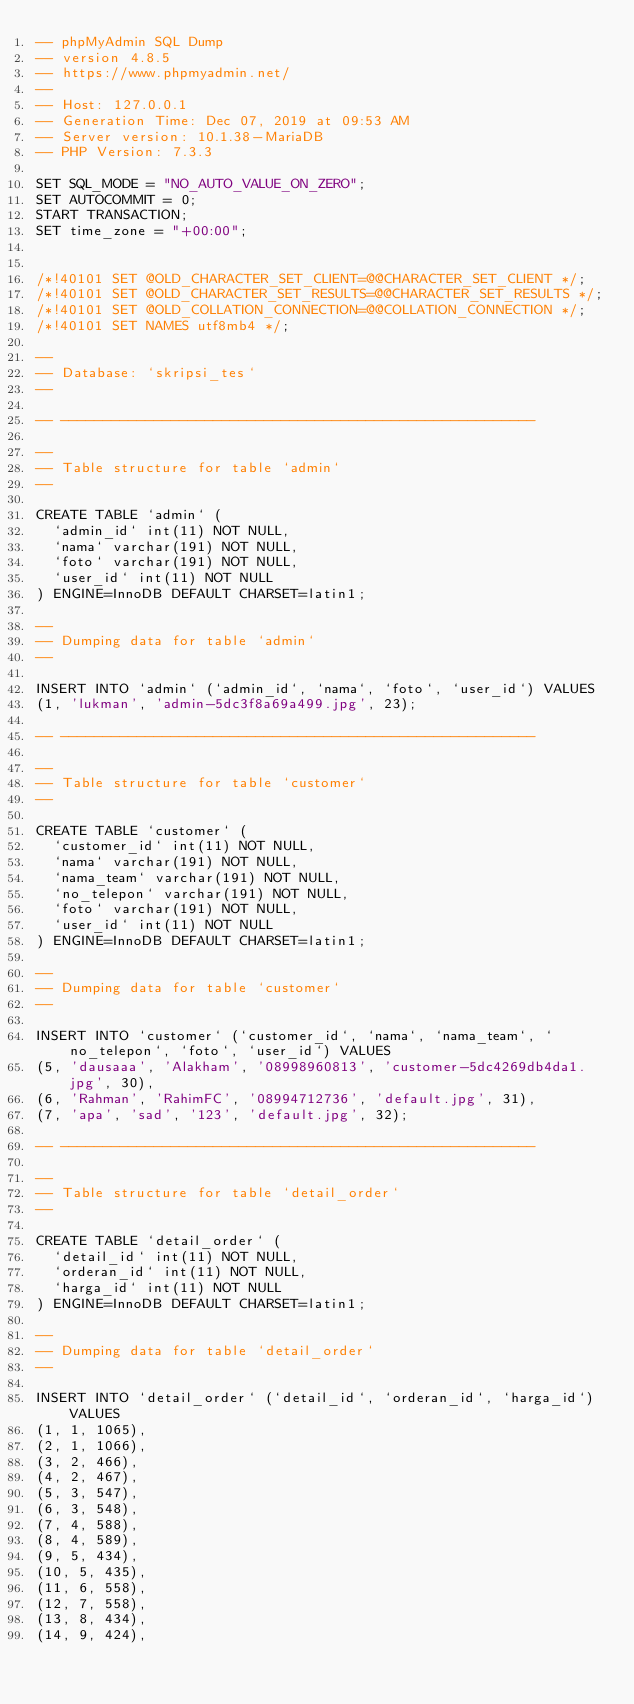Convert code to text. <code><loc_0><loc_0><loc_500><loc_500><_SQL_>-- phpMyAdmin SQL Dump
-- version 4.8.5
-- https://www.phpmyadmin.net/
--
-- Host: 127.0.0.1
-- Generation Time: Dec 07, 2019 at 09:53 AM
-- Server version: 10.1.38-MariaDB
-- PHP Version: 7.3.3

SET SQL_MODE = "NO_AUTO_VALUE_ON_ZERO";
SET AUTOCOMMIT = 0;
START TRANSACTION;
SET time_zone = "+00:00";


/*!40101 SET @OLD_CHARACTER_SET_CLIENT=@@CHARACTER_SET_CLIENT */;
/*!40101 SET @OLD_CHARACTER_SET_RESULTS=@@CHARACTER_SET_RESULTS */;
/*!40101 SET @OLD_COLLATION_CONNECTION=@@COLLATION_CONNECTION */;
/*!40101 SET NAMES utf8mb4 */;

--
-- Database: `skripsi_tes`
--

-- --------------------------------------------------------

--
-- Table structure for table `admin`
--

CREATE TABLE `admin` (
  `admin_id` int(11) NOT NULL,
  `nama` varchar(191) NOT NULL,
  `foto` varchar(191) NOT NULL,
  `user_id` int(11) NOT NULL
) ENGINE=InnoDB DEFAULT CHARSET=latin1;

--
-- Dumping data for table `admin`
--

INSERT INTO `admin` (`admin_id`, `nama`, `foto`, `user_id`) VALUES
(1, 'lukman', 'admin-5dc3f8a69a499.jpg', 23);

-- --------------------------------------------------------

--
-- Table structure for table `customer`
--

CREATE TABLE `customer` (
  `customer_id` int(11) NOT NULL,
  `nama` varchar(191) NOT NULL,
  `nama_team` varchar(191) NOT NULL,
  `no_telepon` varchar(191) NOT NULL,
  `foto` varchar(191) NOT NULL,
  `user_id` int(11) NOT NULL
) ENGINE=InnoDB DEFAULT CHARSET=latin1;

--
-- Dumping data for table `customer`
--

INSERT INTO `customer` (`customer_id`, `nama`, `nama_team`, `no_telepon`, `foto`, `user_id`) VALUES
(5, 'dausaaa', 'Alakham', '08998960813', 'customer-5dc4269db4da1.jpg', 30),
(6, 'Rahman', 'RahimFC', '08994712736', 'default.jpg', 31),
(7, 'apa', 'sad', '123', 'default.jpg', 32);

-- --------------------------------------------------------

--
-- Table structure for table `detail_order`
--

CREATE TABLE `detail_order` (
  `detail_id` int(11) NOT NULL,
  `orderan_id` int(11) NOT NULL,
  `harga_id` int(11) NOT NULL
) ENGINE=InnoDB DEFAULT CHARSET=latin1;

--
-- Dumping data for table `detail_order`
--

INSERT INTO `detail_order` (`detail_id`, `orderan_id`, `harga_id`) VALUES
(1, 1, 1065),
(2, 1, 1066),
(3, 2, 466),
(4, 2, 467),
(5, 3, 547),
(6, 3, 548),
(7, 4, 588),
(8, 4, 589),
(9, 5, 434),
(10, 5, 435),
(11, 6, 558),
(12, 7, 558),
(13, 8, 434),
(14, 9, 424),</code> 